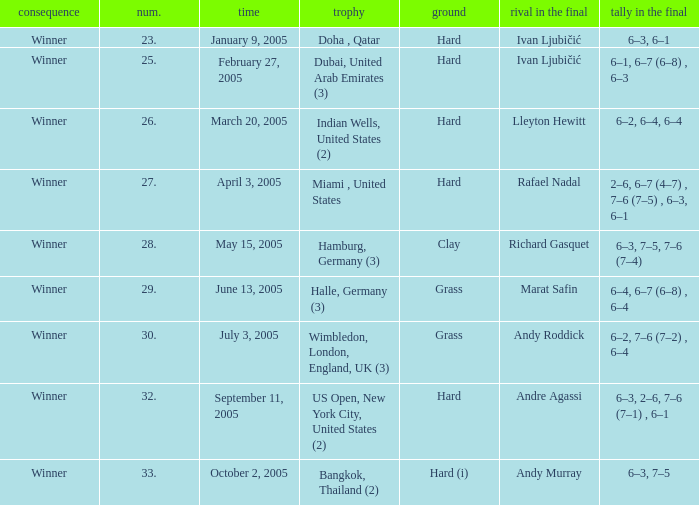How many championships are there on the date January 9, 2005? 1.0. 